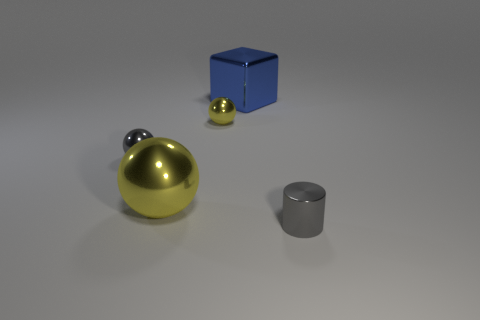Does the cylinder have the same size as the gray ball?
Give a very brief answer. Yes. How many other things are there of the same shape as the blue object?
Your answer should be compact. 0. The large object that is behind the yellow metallic thing to the right of the large yellow sphere is made of what material?
Ensure brevity in your answer.  Metal. There is a big blue shiny thing; are there any large blue objects on the left side of it?
Provide a short and direct response. No. Does the gray cylinder have the same size as the gray shiny thing left of the large shiny block?
Offer a very short reply. Yes. The other yellow thing that is the same shape as the large yellow thing is what size?
Provide a succinct answer. Small. Does the yellow metal object in front of the gray sphere have the same size as the blue metal thing behind the big yellow sphere?
Your answer should be compact. Yes. What number of large things are either cyan shiny objects or metal cylinders?
Your answer should be very brief. 0. How many gray metallic things are to the left of the cylinder and in front of the large yellow ball?
Offer a terse response. 0. How many brown things are either rubber spheres or metallic blocks?
Your answer should be compact. 0. 